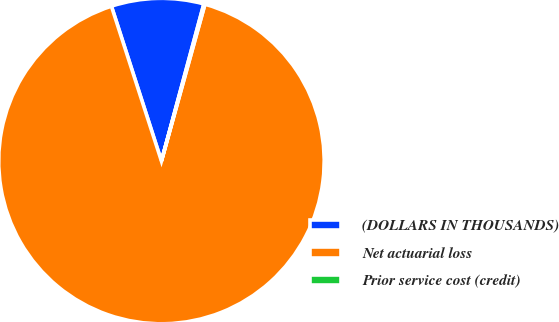<chart> <loc_0><loc_0><loc_500><loc_500><pie_chart><fcel>(DOLLARS IN THOUSANDS)<fcel>Net actuarial loss<fcel>Prior service cost (credit)<nl><fcel>9.17%<fcel>90.72%<fcel>0.11%<nl></chart> 